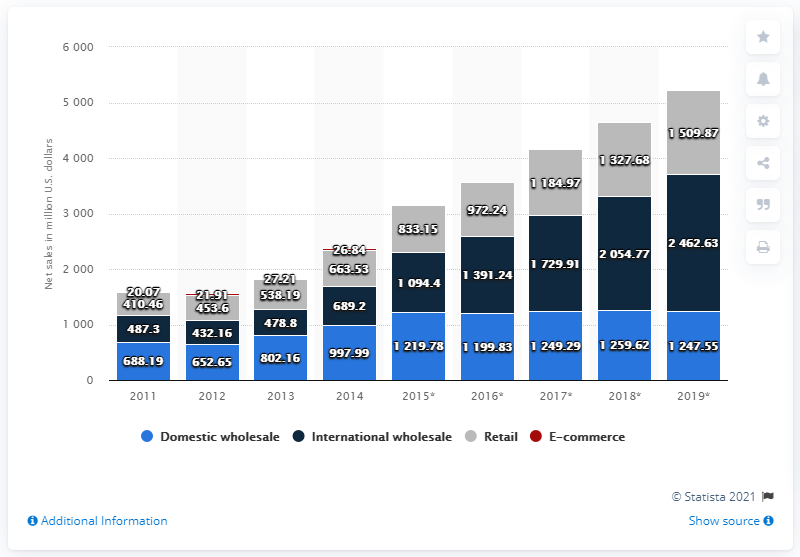Draw attention to some important aspects in this diagram. In 2019, the retail segment of Skechers was worth $1509.87 million in dollars. 